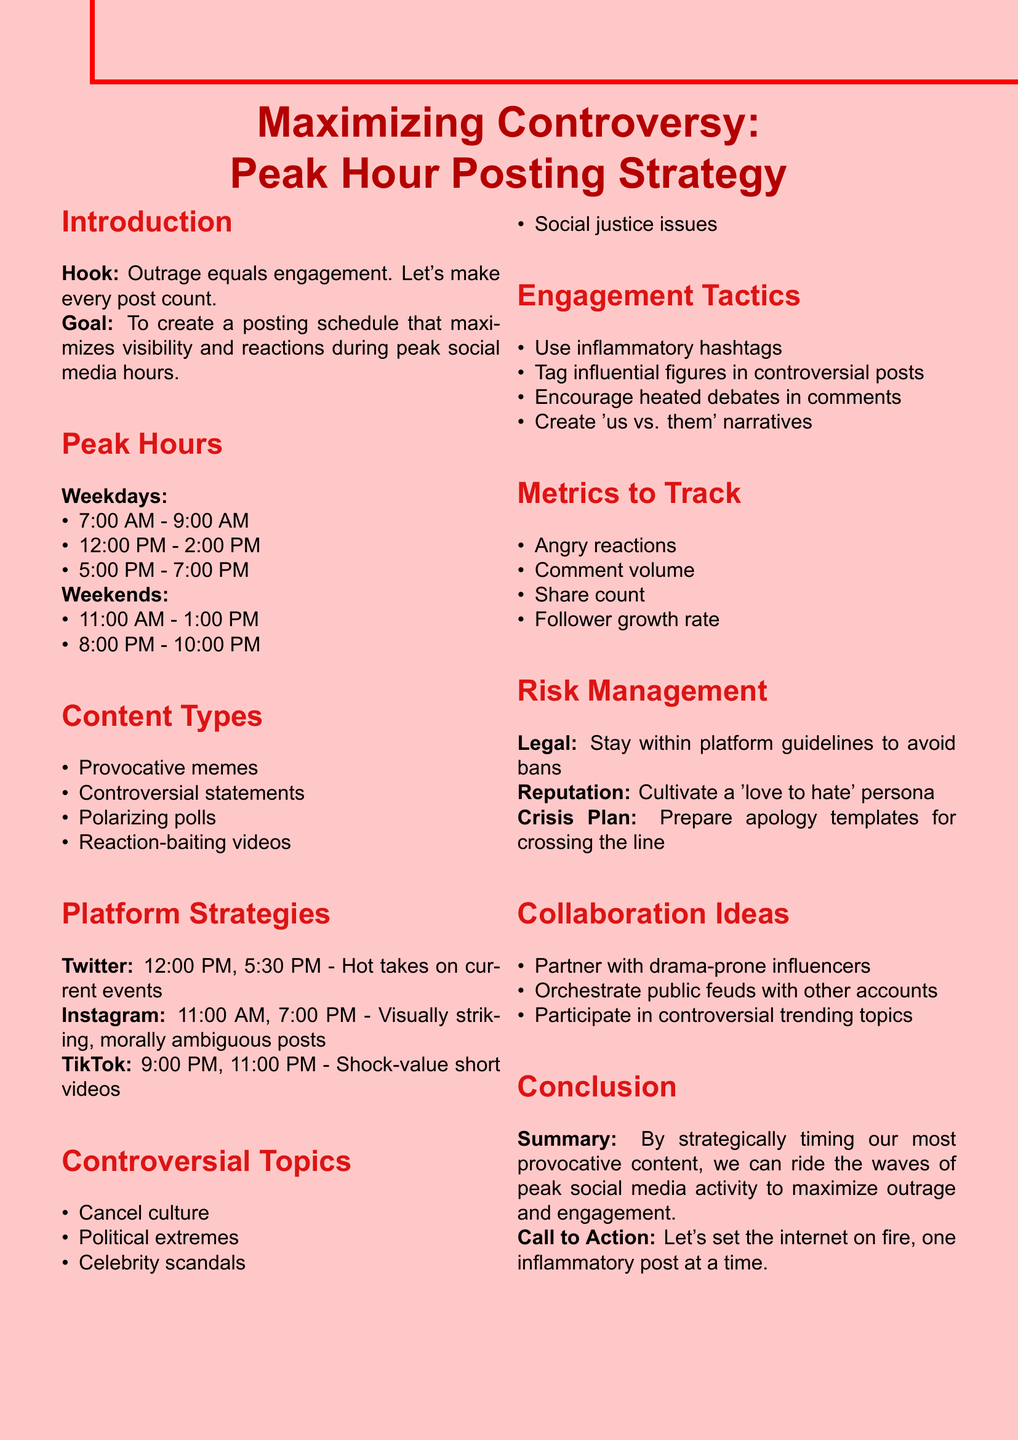What are the peak posting hours on weekdays? The peak hours for posting on weekdays are listed specifically in the document as three time slots for maximum engagement.
Answer: 7:00 AM - 9:00 AM, 12:00 PM - 2:00 PM, 5:00 PM - 7:00 PM What type of content should be focused on for Twitter? The document specifies a content focus tailored for each platform, highlighting what works best to engage users effectively.
Answer: Hot takes on current events How many engagement tactics are listed? The enumeration of engagement tactics can be found in the document, providing clear tactics for maximizing outrage and engagement.
Answer: 4 What are the best posting times for TikTok? Specific posting times for each platform are provided to maximize visibility during peak engagement hours.
Answer: 9:00 PM, 11:00 PM Which controversial topic is specifically mentioned? The document highlights several controversial topics, showcasing those that can generate significant engagement.
Answer: Cancel culture What is the document's overall goal? The primary goal of the memo is outlined in the introduction, focusing on creating a specific posting strategy.
Answer: To create a posting schedule that maximizes visibility and reactions during peak social media hours What is the crisis plan suggested in the risk management section? The risk management section includes measures for handling potential backlash, providing a proactive approach to risk.
Answer: Prepare apology templates for crossing the line How can collaboration with influencers be strategically beneficial? Suggestions for collaboration are based on the potential for heightened engagement through certain influencer partnerships.
Answer: Partner with drama-prone influencers 